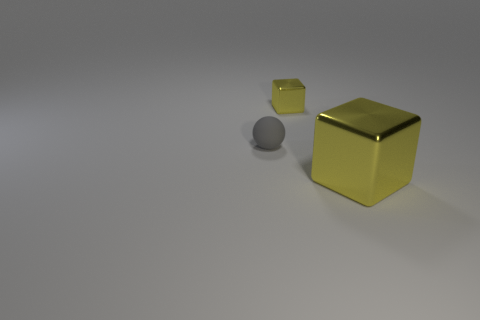Add 3 big yellow metal cubes. How many objects exist? 6 Subtract all balls. How many objects are left? 2 Add 3 small blue cylinders. How many small blue cylinders exist? 3 Subtract 0 brown spheres. How many objects are left? 3 Subtract all large yellow things. Subtract all shiny spheres. How many objects are left? 2 Add 1 yellow metallic cubes. How many yellow metallic cubes are left? 3 